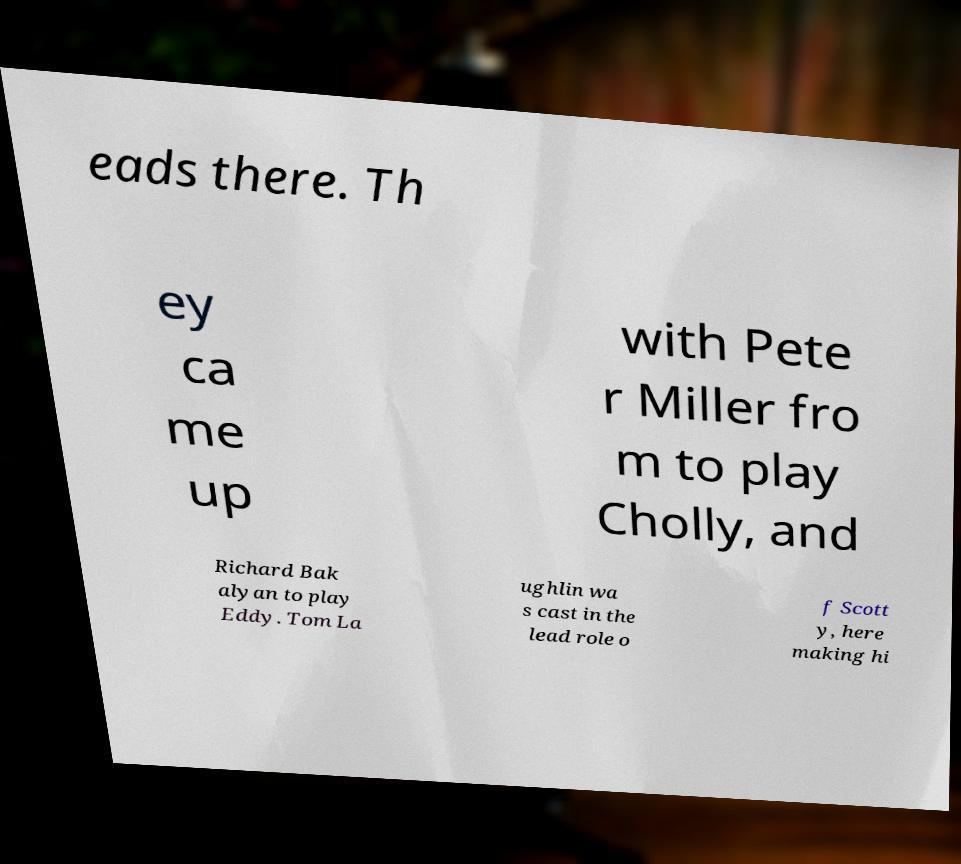There's text embedded in this image that I need extracted. Can you transcribe it verbatim? eads there. Th ey ca me up with Pete r Miller fro m to play Cholly, and Richard Bak alyan to play Eddy. Tom La ughlin wa s cast in the lead role o f Scott y, here making hi 